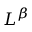Convert formula to latex. <formula><loc_0><loc_0><loc_500><loc_500>L ^ { \beta }</formula> 